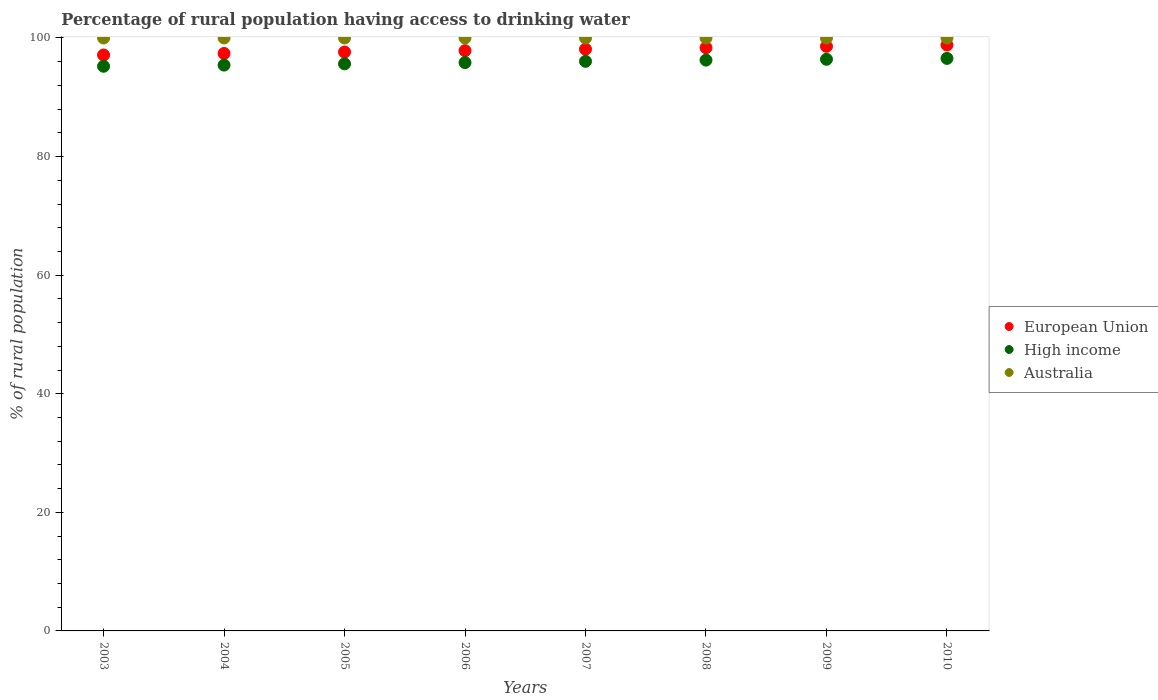How many different coloured dotlines are there?
Provide a succinct answer. 3. Is the number of dotlines equal to the number of legend labels?
Provide a short and direct response. Yes. What is the percentage of rural population having access to drinking water in Australia in 2008?
Make the answer very short. 100. Across all years, what is the maximum percentage of rural population having access to drinking water in Australia?
Ensure brevity in your answer.  100. Across all years, what is the minimum percentage of rural population having access to drinking water in High income?
Ensure brevity in your answer.  95.23. In which year was the percentage of rural population having access to drinking water in High income maximum?
Ensure brevity in your answer.  2010. In which year was the percentage of rural population having access to drinking water in European Union minimum?
Ensure brevity in your answer.  2003. What is the total percentage of rural population having access to drinking water in European Union in the graph?
Give a very brief answer. 783.89. What is the difference between the percentage of rural population having access to drinking water in European Union in 2006 and that in 2007?
Provide a short and direct response. -0.24. What is the difference between the percentage of rural population having access to drinking water in Australia in 2003 and the percentage of rural population having access to drinking water in High income in 2009?
Ensure brevity in your answer.  3.59. What is the average percentage of rural population having access to drinking water in European Union per year?
Offer a terse response. 97.99. In the year 2007, what is the difference between the percentage of rural population having access to drinking water in European Union and percentage of rural population having access to drinking water in Australia?
Your answer should be very brief. -1.89. In how many years, is the percentage of rural population having access to drinking water in High income greater than 88 %?
Make the answer very short. 8. What is the ratio of the percentage of rural population having access to drinking water in European Union in 2004 to that in 2006?
Your answer should be compact. 1. Is the percentage of rural population having access to drinking water in High income in 2003 less than that in 2006?
Give a very brief answer. Yes. Is the difference between the percentage of rural population having access to drinking water in European Union in 2007 and 2008 greater than the difference between the percentage of rural population having access to drinking water in Australia in 2007 and 2008?
Ensure brevity in your answer.  No. What is the difference between the highest and the second highest percentage of rural population having access to drinking water in High income?
Offer a terse response. 0.15. What is the difference between the highest and the lowest percentage of rural population having access to drinking water in European Union?
Your response must be concise. 1.68. Is it the case that in every year, the sum of the percentage of rural population having access to drinking water in European Union and percentage of rural population having access to drinking water in Australia  is greater than the percentage of rural population having access to drinking water in High income?
Your answer should be compact. Yes. Is the percentage of rural population having access to drinking water in European Union strictly less than the percentage of rural population having access to drinking water in Australia over the years?
Keep it short and to the point. Yes. How many dotlines are there?
Offer a terse response. 3. Are the values on the major ticks of Y-axis written in scientific E-notation?
Your answer should be very brief. No. Where does the legend appear in the graph?
Offer a very short reply. Center right. How many legend labels are there?
Give a very brief answer. 3. What is the title of the graph?
Keep it short and to the point. Percentage of rural population having access to drinking water. Does "Palau" appear as one of the legend labels in the graph?
Keep it short and to the point. No. What is the label or title of the X-axis?
Your answer should be compact. Years. What is the label or title of the Y-axis?
Your response must be concise. % of rural population. What is the % of rural population in European Union in 2003?
Keep it short and to the point. 97.13. What is the % of rural population in High income in 2003?
Offer a very short reply. 95.23. What is the % of rural population of Australia in 2003?
Offer a very short reply. 100. What is the % of rural population in European Union in 2004?
Provide a short and direct response. 97.39. What is the % of rural population of High income in 2004?
Your response must be concise. 95.43. What is the % of rural population of Australia in 2004?
Your answer should be very brief. 100. What is the % of rural population of European Union in 2005?
Your response must be concise. 97.63. What is the % of rural population in High income in 2005?
Keep it short and to the point. 95.64. What is the % of rural population in Australia in 2005?
Your answer should be very brief. 100. What is the % of rural population in European Union in 2006?
Provide a short and direct response. 97.87. What is the % of rural population of High income in 2006?
Ensure brevity in your answer.  95.85. What is the % of rural population of Australia in 2006?
Offer a terse response. 100. What is the % of rural population of European Union in 2007?
Make the answer very short. 98.11. What is the % of rural population of High income in 2007?
Offer a terse response. 96.06. What is the % of rural population of Australia in 2007?
Offer a terse response. 100. What is the % of rural population of European Union in 2008?
Ensure brevity in your answer.  98.35. What is the % of rural population in High income in 2008?
Offer a very short reply. 96.27. What is the % of rural population of Australia in 2008?
Your answer should be very brief. 100. What is the % of rural population in European Union in 2009?
Offer a terse response. 98.59. What is the % of rural population of High income in 2009?
Your response must be concise. 96.41. What is the % of rural population in Australia in 2009?
Make the answer very short. 100. What is the % of rural population of European Union in 2010?
Provide a succinct answer. 98.81. What is the % of rural population of High income in 2010?
Provide a short and direct response. 96.56. What is the % of rural population of Australia in 2010?
Your answer should be very brief. 100. Across all years, what is the maximum % of rural population of European Union?
Ensure brevity in your answer.  98.81. Across all years, what is the maximum % of rural population in High income?
Keep it short and to the point. 96.56. Across all years, what is the maximum % of rural population in Australia?
Give a very brief answer. 100. Across all years, what is the minimum % of rural population of European Union?
Offer a terse response. 97.13. Across all years, what is the minimum % of rural population of High income?
Keep it short and to the point. 95.23. Across all years, what is the minimum % of rural population of Australia?
Keep it short and to the point. 100. What is the total % of rural population of European Union in the graph?
Give a very brief answer. 783.89. What is the total % of rural population of High income in the graph?
Keep it short and to the point. 767.45. What is the total % of rural population in Australia in the graph?
Make the answer very short. 800. What is the difference between the % of rural population of European Union in 2003 and that in 2004?
Ensure brevity in your answer.  -0.26. What is the difference between the % of rural population of High income in 2003 and that in 2004?
Offer a terse response. -0.2. What is the difference between the % of rural population of Australia in 2003 and that in 2004?
Provide a succinct answer. 0. What is the difference between the % of rural population of European Union in 2003 and that in 2005?
Your answer should be very brief. -0.5. What is the difference between the % of rural population in High income in 2003 and that in 2005?
Your response must be concise. -0.41. What is the difference between the % of rural population in European Union in 2003 and that in 2006?
Keep it short and to the point. -0.73. What is the difference between the % of rural population in High income in 2003 and that in 2006?
Give a very brief answer. -0.62. What is the difference between the % of rural population in Australia in 2003 and that in 2006?
Offer a terse response. 0. What is the difference between the % of rural population in European Union in 2003 and that in 2007?
Your answer should be compact. -0.98. What is the difference between the % of rural population in High income in 2003 and that in 2007?
Your response must be concise. -0.83. What is the difference between the % of rural population of Australia in 2003 and that in 2007?
Your answer should be very brief. 0. What is the difference between the % of rural population of European Union in 2003 and that in 2008?
Offer a terse response. -1.22. What is the difference between the % of rural population in High income in 2003 and that in 2008?
Your answer should be compact. -1.04. What is the difference between the % of rural population in European Union in 2003 and that in 2009?
Provide a succinct answer. -1.46. What is the difference between the % of rural population in High income in 2003 and that in 2009?
Ensure brevity in your answer.  -1.18. What is the difference between the % of rural population in European Union in 2003 and that in 2010?
Provide a succinct answer. -1.68. What is the difference between the % of rural population in High income in 2003 and that in 2010?
Offer a terse response. -1.33. What is the difference between the % of rural population in European Union in 2004 and that in 2005?
Make the answer very short. -0.24. What is the difference between the % of rural population of High income in 2004 and that in 2005?
Offer a terse response. -0.21. What is the difference between the % of rural population in Australia in 2004 and that in 2005?
Provide a succinct answer. 0. What is the difference between the % of rural population of European Union in 2004 and that in 2006?
Give a very brief answer. -0.48. What is the difference between the % of rural population in High income in 2004 and that in 2006?
Offer a terse response. -0.43. What is the difference between the % of rural population of Australia in 2004 and that in 2006?
Your answer should be very brief. 0. What is the difference between the % of rural population of European Union in 2004 and that in 2007?
Provide a short and direct response. -0.72. What is the difference between the % of rural population in High income in 2004 and that in 2007?
Provide a succinct answer. -0.64. What is the difference between the % of rural population of Australia in 2004 and that in 2007?
Provide a succinct answer. 0. What is the difference between the % of rural population of European Union in 2004 and that in 2008?
Your response must be concise. -0.96. What is the difference between the % of rural population of High income in 2004 and that in 2008?
Provide a succinct answer. -0.84. What is the difference between the % of rural population in Australia in 2004 and that in 2008?
Offer a very short reply. 0. What is the difference between the % of rural population of European Union in 2004 and that in 2009?
Your response must be concise. -1.2. What is the difference between the % of rural population of High income in 2004 and that in 2009?
Give a very brief answer. -0.98. What is the difference between the % of rural population in Australia in 2004 and that in 2009?
Your answer should be very brief. 0. What is the difference between the % of rural population of European Union in 2004 and that in 2010?
Provide a succinct answer. -1.42. What is the difference between the % of rural population in High income in 2004 and that in 2010?
Your answer should be compact. -1.13. What is the difference between the % of rural population in Australia in 2004 and that in 2010?
Your answer should be very brief. 0. What is the difference between the % of rural population in European Union in 2005 and that in 2006?
Provide a short and direct response. -0.24. What is the difference between the % of rural population of High income in 2005 and that in 2006?
Offer a very short reply. -0.21. What is the difference between the % of rural population of European Union in 2005 and that in 2007?
Offer a terse response. -0.48. What is the difference between the % of rural population in High income in 2005 and that in 2007?
Your response must be concise. -0.42. What is the difference between the % of rural population in European Union in 2005 and that in 2008?
Your response must be concise. -0.72. What is the difference between the % of rural population of High income in 2005 and that in 2008?
Your answer should be compact. -0.63. What is the difference between the % of rural population of European Union in 2005 and that in 2009?
Ensure brevity in your answer.  -0.96. What is the difference between the % of rural population in High income in 2005 and that in 2009?
Provide a succinct answer. -0.77. What is the difference between the % of rural population of Australia in 2005 and that in 2009?
Provide a succinct answer. 0. What is the difference between the % of rural population in European Union in 2005 and that in 2010?
Make the answer very short. -1.18. What is the difference between the % of rural population in High income in 2005 and that in 2010?
Your answer should be compact. -0.92. What is the difference between the % of rural population in Australia in 2005 and that in 2010?
Provide a short and direct response. 0. What is the difference between the % of rural population in European Union in 2006 and that in 2007?
Make the answer very short. -0.24. What is the difference between the % of rural population of High income in 2006 and that in 2007?
Offer a terse response. -0.21. What is the difference between the % of rural population in European Union in 2006 and that in 2008?
Your answer should be very brief. -0.49. What is the difference between the % of rural population in High income in 2006 and that in 2008?
Keep it short and to the point. -0.41. What is the difference between the % of rural population in European Union in 2006 and that in 2009?
Your answer should be compact. -0.72. What is the difference between the % of rural population of High income in 2006 and that in 2009?
Provide a short and direct response. -0.55. What is the difference between the % of rural population in European Union in 2006 and that in 2010?
Your response must be concise. -0.95. What is the difference between the % of rural population of High income in 2006 and that in 2010?
Ensure brevity in your answer.  -0.7. What is the difference between the % of rural population of European Union in 2007 and that in 2008?
Make the answer very short. -0.24. What is the difference between the % of rural population of High income in 2007 and that in 2008?
Your response must be concise. -0.21. What is the difference between the % of rural population of Australia in 2007 and that in 2008?
Provide a succinct answer. 0. What is the difference between the % of rural population in European Union in 2007 and that in 2009?
Provide a short and direct response. -0.48. What is the difference between the % of rural population of High income in 2007 and that in 2009?
Offer a terse response. -0.34. What is the difference between the % of rural population of Australia in 2007 and that in 2009?
Your answer should be compact. 0. What is the difference between the % of rural population in European Union in 2007 and that in 2010?
Make the answer very short. -0.7. What is the difference between the % of rural population in High income in 2007 and that in 2010?
Your answer should be compact. -0.49. What is the difference between the % of rural population of Australia in 2007 and that in 2010?
Your answer should be very brief. 0. What is the difference between the % of rural population in European Union in 2008 and that in 2009?
Make the answer very short. -0.24. What is the difference between the % of rural population in High income in 2008 and that in 2009?
Offer a very short reply. -0.14. What is the difference between the % of rural population of Australia in 2008 and that in 2009?
Ensure brevity in your answer.  0. What is the difference between the % of rural population in European Union in 2008 and that in 2010?
Provide a succinct answer. -0.46. What is the difference between the % of rural population of High income in 2008 and that in 2010?
Provide a succinct answer. -0.29. What is the difference between the % of rural population of Australia in 2008 and that in 2010?
Provide a succinct answer. 0. What is the difference between the % of rural population in European Union in 2009 and that in 2010?
Ensure brevity in your answer.  -0.22. What is the difference between the % of rural population in High income in 2009 and that in 2010?
Provide a short and direct response. -0.15. What is the difference between the % of rural population in European Union in 2003 and the % of rural population in High income in 2004?
Provide a succinct answer. 1.71. What is the difference between the % of rural population of European Union in 2003 and the % of rural population of Australia in 2004?
Your response must be concise. -2.87. What is the difference between the % of rural population in High income in 2003 and the % of rural population in Australia in 2004?
Keep it short and to the point. -4.77. What is the difference between the % of rural population in European Union in 2003 and the % of rural population in High income in 2005?
Offer a very short reply. 1.49. What is the difference between the % of rural population of European Union in 2003 and the % of rural population of Australia in 2005?
Keep it short and to the point. -2.87. What is the difference between the % of rural population of High income in 2003 and the % of rural population of Australia in 2005?
Your answer should be compact. -4.77. What is the difference between the % of rural population in European Union in 2003 and the % of rural population in High income in 2006?
Your answer should be compact. 1.28. What is the difference between the % of rural population in European Union in 2003 and the % of rural population in Australia in 2006?
Offer a terse response. -2.87. What is the difference between the % of rural population of High income in 2003 and the % of rural population of Australia in 2006?
Ensure brevity in your answer.  -4.77. What is the difference between the % of rural population in European Union in 2003 and the % of rural population in High income in 2007?
Keep it short and to the point. 1.07. What is the difference between the % of rural population of European Union in 2003 and the % of rural population of Australia in 2007?
Give a very brief answer. -2.87. What is the difference between the % of rural population of High income in 2003 and the % of rural population of Australia in 2007?
Give a very brief answer. -4.77. What is the difference between the % of rural population in European Union in 2003 and the % of rural population in High income in 2008?
Make the answer very short. 0.86. What is the difference between the % of rural population of European Union in 2003 and the % of rural population of Australia in 2008?
Give a very brief answer. -2.87. What is the difference between the % of rural population of High income in 2003 and the % of rural population of Australia in 2008?
Make the answer very short. -4.77. What is the difference between the % of rural population of European Union in 2003 and the % of rural population of High income in 2009?
Make the answer very short. 0.73. What is the difference between the % of rural population in European Union in 2003 and the % of rural population in Australia in 2009?
Offer a very short reply. -2.87. What is the difference between the % of rural population of High income in 2003 and the % of rural population of Australia in 2009?
Ensure brevity in your answer.  -4.77. What is the difference between the % of rural population of European Union in 2003 and the % of rural population of High income in 2010?
Your answer should be compact. 0.58. What is the difference between the % of rural population of European Union in 2003 and the % of rural population of Australia in 2010?
Your answer should be very brief. -2.87. What is the difference between the % of rural population of High income in 2003 and the % of rural population of Australia in 2010?
Offer a terse response. -4.77. What is the difference between the % of rural population in European Union in 2004 and the % of rural population in High income in 2005?
Your response must be concise. 1.75. What is the difference between the % of rural population in European Union in 2004 and the % of rural population in Australia in 2005?
Make the answer very short. -2.61. What is the difference between the % of rural population of High income in 2004 and the % of rural population of Australia in 2005?
Provide a short and direct response. -4.57. What is the difference between the % of rural population of European Union in 2004 and the % of rural population of High income in 2006?
Your answer should be compact. 1.54. What is the difference between the % of rural population of European Union in 2004 and the % of rural population of Australia in 2006?
Your response must be concise. -2.61. What is the difference between the % of rural population of High income in 2004 and the % of rural population of Australia in 2006?
Your answer should be compact. -4.57. What is the difference between the % of rural population of European Union in 2004 and the % of rural population of High income in 2007?
Provide a short and direct response. 1.33. What is the difference between the % of rural population of European Union in 2004 and the % of rural population of Australia in 2007?
Provide a short and direct response. -2.61. What is the difference between the % of rural population in High income in 2004 and the % of rural population in Australia in 2007?
Provide a short and direct response. -4.57. What is the difference between the % of rural population of European Union in 2004 and the % of rural population of High income in 2008?
Your answer should be compact. 1.12. What is the difference between the % of rural population of European Union in 2004 and the % of rural population of Australia in 2008?
Your answer should be very brief. -2.61. What is the difference between the % of rural population in High income in 2004 and the % of rural population in Australia in 2008?
Your answer should be compact. -4.57. What is the difference between the % of rural population in European Union in 2004 and the % of rural population in High income in 2009?
Provide a short and direct response. 0.98. What is the difference between the % of rural population of European Union in 2004 and the % of rural population of Australia in 2009?
Make the answer very short. -2.61. What is the difference between the % of rural population in High income in 2004 and the % of rural population in Australia in 2009?
Keep it short and to the point. -4.57. What is the difference between the % of rural population of European Union in 2004 and the % of rural population of High income in 2010?
Offer a terse response. 0.83. What is the difference between the % of rural population in European Union in 2004 and the % of rural population in Australia in 2010?
Ensure brevity in your answer.  -2.61. What is the difference between the % of rural population of High income in 2004 and the % of rural population of Australia in 2010?
Offer a very short reply. -4.57. What is the difference between the % of rural population of European Union in 2005 and the % of rural population of High income in 2006?
Ensure brevity in your answer.  1.78. What is the difference between the % of rural population of European Union in 2005 and the % of rural population of Australia in 2006?
Your response must be concise. -2.37. What is the difference between the % of rural population in High income in 2005 and the % of rural population in Australia in 2006?
Provide a succinct answer. -4.36. What is the difference between the % of rural population of European Union in 2005 and the % of rural population of High income in 2007?
Give a very brief answer. 1.57. What is the difference between the % of rural population in European Union in 2005 and the % of rural population in Australia in 2007?
Offer a terse response. -2.37. What is the difference between the % of rural population in High income in 2005 and the % of rural population in Australia in 2007?
Give a very brief answer. -4.36. What is the difference between the % of rural population of European Union in 2005 and the % of rural population of High income in 2008?
Keep it short and to the point. 1.36. What is the difference between the % of rural population of European Union in 2005 and the % of rural population of Australia in 2008?
Offer a very short reply. -2.37. What is the difference between the % of rural population in High income in 2005 and the % of rural population in Australia in 2008?
Ensure brevity in your answer.  -4.36. What is the difference between the % of rural population in European Union in 2005 and the % of rural population in High income in 2009?
Offer a very short reply. 1.22. What is the difference between the % of rural population of European Union in 2005 and the % of rural population of Australia in 2009?
Keep it short and to the point. -2.37. What is the difference between the % of rural population in High income in 2005 and the % of rural population in Australia in 2009?
Give a very brief answer. -4.36. What is the difference between the % of rural population of European Union in 2005 and the % of rural population of High income in 2010?
Keep it short and to the point. 1.07. What is the difference between the % of rural population in European Union in 2005 and the % of rural population in Australia in 2010?
Offer a terse response. -2.37. What is the difference between the % of rural population in High income in 2005 and the % of rural population in Australia in 2010?
Offer a terse response. -4.36. What is the difference between the % of rural population in European Union in 2006 and the % of rural population in High income in 2007?
Make the answer very short. 1.8. What is the difference between the % of rural population of European Union in 2006 and the % of rural population of Australia in 2007?
Make the answer very short. -2.13. What is the difference between the % of rural population of High income in 2006 and the % of rural population of Australia in 2007?
Provide a succinct answer. -4.15. What is the difference between the % of rural population of European Union in 2006 and the % of rural population of High income in 2008?
Your answer should be compact. 1.6. What is the difference between the % of rural population of European Union in 2006 and the % of rural population of Australia in 2008?
Offer a very short reply. -2.13. What is the difference between the % of rural population in High income in 2006 and the % of rural population in Australia in 2008?
Keep it short and to the point. -4.15. What is the difference between the % of rural population in European Union in 2006 and the % of rural population in High income in 2009?
Your answer should be compact. 1.46. What is the difference between the % of rural population in European Union in 2006 and the % of rural population in Australia in 2009?
Your response must be concise. -2.13. What is the difference between the % of rural population of High income in 2006 and the % of rural population of Australia in 2009?
Keep it short and to the point. -4.15. What is the difference between the % of rural population of European Union in 2006 and the % of rural population of High income in 2010?
Ensure brevity in your answer.  1.31. What is the difference between the % of rural population of European Union in 2006 and the % of rural population of Australia in 2010?
Keep it short and to the point. -2.13. What is the difference between the % of rural population of High income in 2006 and the % of rural population of Australia in 2010?
Offer a terse response. -4.15. What is the difference between the % of rural population of European Union in 2007 and the % of rural population of High income in 2008?
Provide a succinct answer. 1.84. What is the difference between the % of rural population of European Union in 2007 and the % of rural population of Australia in 2008?
Your answer should be very brief. -1.89. What is the difference between the % of rural population in High income in 2007 and the % of rural population in Australia in 2008?
Offer a very short reply. -3.94. What is the difference between the % of rural population in European Union in 2007 and the % of rural population in High income in 2009?
Your response must be concise. 1.7. What is the difference between the % of rural population of European Union in 2007 and the % of rural population of Australia in 2009?
Ensure brevity in your answer.  -1.89. What is the difference between the % of rural population in High income in 2007 and the % of rural population in Australia in 2009?
Keep it short and to the point. -3.94. What is the difference between the % of rural population in European Union in 2007 and the % of rural population in High income in 2010?
Offer a very short reply. 1.55. What is the difference between the % of rural population of European Union in 2007 and the % of rural population of Australia in 2010?
Make the answer very short. -1.89. What is the difference between the % of rural population in High income in 2007 and the % of rural population in Australia in 2010?
Provide a succinct answer. -3.94. What is the difference between the % of rural population of European Union in 2008 and the % of rural population of High income in 2009?
Ensure brevity in your answer.  1.95. What is the difference between the % of rural population of European Union in 2008 and the % of rural population of Australia in 2009?
Provide a short and direct response. -1.65. What is the difference between the % of rural population in High income in 2008 and the % of rural population in Australia in 2009?
Your response must be concise. -3.73. What is the difference between the % of rural population of European Union in 2008 and the % of rural population of High income in 2010?
Provide a succinct answer. 1.8. What is the difference between the % of rural population in European Union in 2008 and the % of rural population in Australia in 2010?
Keep it short and to the point. -1.65. What is the difference between the % of rural population in High income in 2008 and the % of rural population in Australia in 2010?
Give a very brief answer. -3.73. What is the difference between the % of rural population in European Union in 2009 and the % of rural population in High income in 2010?
Provide a succinct answer. 2.03. What is the difference between the % of rural population in European Union in 2009 and the % of rural population in Australia in 2010?
Make the answer very short. -1.41. What is the difference between the % of rural population of High income in 2009 and the % of rural population of Australia in 2010?
Ensure brevity in your answer.  -3.59. What is the average % of rural population in European Union per year?
Ensure brevity in your answer.  97.99. What is the average % of rural population of High income per year?
Keep it short and to the point. 95.93. In the year 2003, what is the difference between the % of rural population of European Union and % of rural population of High income?
Make the answer very short. 1.9. In the year 2003, what is the difference between the % of rural population in European Union and % of rural population in Australia?
Your answer should be compact. -2.87. In the year 2003, what is the difference between the % of rural population in High income and % of rural population in Australia?
Your response must be concise. -4.77. In the year 2004, what is the difference between the % of rural population in European Union and % of rural population in High income?
Give a very brief answer. 1.96. In the year 2004, what is the difference between the % of rural population in European Union and % of rural population in Australia?
Provide a succinct answer. -2.61. In the year 2004, what is the difference between the % of rural population of High income and % of rural population of Australia?
Your answer should be very brief. -4.57. In the year 2005, what is the difference between the % of rural population of European Union and % of rural population of High income?
Offer a very short reply. 1.99. In the year 2005, what is the difference between the % of rural population in European Union and % of rural population in Australia?
Your response must be concise. -2.37. In the year 2005, what is the difference between the % of rural population of High income and % of rural population of Australia?
Provide a short and direct response. -4.36. In the year 2006, what is the difference between the % of rural population in European Union and % of rural population in High income?
Give a very brief answer. 2.01. In the year 2006, what is the difference between the % of rural population of European Union and % of rural population of Australia?
Offer a very short reply. -2.13. In the year 2006, what is the difference between the % of rural population in High income and % of rural population in Australia?
Your response must be concise. -4.15. In the year 2007, what is the difference between the % of rural population of European Union and % of rural population of High income?
Your answer should be compact. 2.05. In the year 2007, what is the difference between the % of rural population of European Union and % of rural population of Australia?
Offer a very short reply. -1.89. In the year 2007, what is the difference between the % of rural population of High income and % of rural population of Australia?
Keep it short and to the point. -3.94. In the year 2008, what is the difference between the % of rural population in European Union and % of rural population in High income?
Provide a short and direct response. 2.08. In the year 2008, what is the difference between the % of rural population of European Union and % of rural population of Australia?
Your response must be concise. -1.65. In the year 2008, what is the difference between the % of rural population in High income and % of rural population in Australia?
Provide a short and direct response. -3.73. In the year 2009, what is the difference between the % of rural population of European Union and % of rural population of High income?
Your answer should be very brief. 2.18. In the year 2009, what is the difference between the % of rural population in European Union and % of rural population in Australia?
Provide a short and direct response. -1.41. In the year 2009, what is the difference between the % of rural population of High income and % of rural population of Australia?
Provide a succinct answer. -3.59. In the year 2010, what is the difference between the % of rural population of European Union and % of rural population of High income?
Provide a succinct answer. 2.26. In the year 2010, what is the difference between the % of rural population of European Union and % of rural population of Australia?
Give a very brief answer. -1.19. In the year 2010, what is the difference between the % of rural population in High income and % of rural population in Australia?
Make the answer very short. -3.44. What is the ratio of the % of rural population in Australia in 2003 to that in 2004?
Your answer should be very brief. 1. What is the ratio of the % of rural population in European Union in 2003 to that in 2005?
Provide a succinct answer. 0.99. What is the ratio of the % of rural population in High income in 2003 to that in 2005?
Your answer should be compact. 1. What is the ratio of the % of rural population in European Union in 2003 to that in 2006?
Keep it short and to the point. 0.99. What is the ratio of the % of rural population in High income in 2003 to that in 2006?
Ensure brevity in your answer.  0.99. What is the ratio of the % of rural population of Australia in 2003 to that in 2006?
Keep it short and to the point. 1. What is the ratio of the % of rural population of High income in 2003 to that in 2007?
Ensure brevity in your answer.  0.99. What is the ratio of the % of rural population of European Union in 2003 to that in 2008?
Your answer should be compact. 0.99. What is the ratio of the % of rural population of European Union in 2003 to that in 2009?
Provide a succinct answer. 0.99. What is the ratio of the % of rural population of High income in 2003 to that in 2010?
Offer a terse response. 0.99. What is the ratio of the % of rural population in European Union in 2004 to that in 2005?
Your response must be concise. 1. What is the ratio of the % of rural population of High income in 2004 to that in 2005?
Provide a short and direct response. 1. What is the ratio of the % of rural population of Australia in 2004 to that in 2005?
Your response must be concise. 1. What is the ratio of the % of rural population in European Union in 2004 to that in 2006?
Give a very brief answer. 1. What is the ratio of the % of rural population in High income in 2004 to that in 2006?
Ensure brevity in your answer.  1. What is the ratio of the % of rural population of High income in 2004 to that in 2007?
Ensure brevity in your answer.  0.99. What is the ratio of the % of rural population of Australia in 2004 to that in 2007?
Make the answer very short. 1. What is the ratio of the % of rural population in European Union in 2004 to that in 2008?
Offer a terse response. 0.99. What is the ratio of the % of rural population in High income in 2004 to that in 2009?
Offer a very short reply. 0.99. What is the ratio of the % of rural population in European Union in 2004 to that in 2010?
Offer a terse response. 0.99. What is the ratio of the % of rural population in High income in 2004 to that in 2010?
Your response must be concise. 0.99. What is the ratio of the % of rural population in Australia in 2004 to that in 2010?
Offer a terse response. 1. What is the ratio of the % of rural population of European Union in 2005 to that in 2006?
Keep it short and to the point. 1. What is the ratio of the % of rural population of High income in 2005 to that in 2006?
Make the answer very short. 1. What is the ratio of the % of rural population of European Union in 2005 to that in 2007?
Offer a terse response. 1. What is the ratio of the % of rural population of European Union in 2005 to that in 2008?
Offer a terse response. 0.99. What is the ratio of the % of rural population of European Union in 2005 to that in 2009?
Offer a terse response. 0.99. What is the ratio of the % of rural population in High income in 2005 to that in 2009?
Keep it short and to the point. 0.99. What is the ratio of the % of rural population of Australia in 2006 to that in 2007?
Your answer should be compact. 1. What is the ratio of the % of rural population in European Union in 2006 to that in 2008?
Your answer should be compact. 1. What is the ratio of the % of rural population of High income in 2006 to that in 2008?
Offer a terse response. 1. What is the ratio of the % of rural population in Australia in 2006 to that in 2008?
Make the answer very short. 1. What is the ratio of the % of rural population in European Union in 2006 to that in 2009?
Your response must be concise. 0.99. What is the ratio of the % of rural population of High income in 2006 to that in 2009?
Ensure brevity in your answer.  0.99. What is the ratio of the % of rural population of Australia in 2006 to that in 2009?
Make the answer very short. 1. What is the ratio of the % of rural population in European Union in 2007 to that in 2008?
Provide a short and direct response. 1. What is the ratio of the % of rural population of High income in 2007 to that in 2009?
Give a very brief answer. 1. What is the ratio of the % of rural population of Australia in 2007 to that in 2009?
Keep it short and to the point. 1. What is the ratio of the % of rural population in European Union in 2007 to that in 2010?
Give a very brief answer. 0.99. What is the ratio of the % of rural population in High income in 2007 to that in 2010?
Keep it short and to the point. 0.99. What is the ratio of the % of rural population in Australia in 2007 to that in 2010?
Offer a terse response. 1. What is the ratio of the % of rural population in European Union in 2008 to that in 2010?
Offer a terse response. 1. What is the ratio of the % of rural population of Australia in 2008 to that in 2010?
Give a very brief answer. 1. What is the ratio of the % of rural population of European Union in 2009 to that in 2010?
Provide a succinct answer. 1. What is the ratio of the % of rural population of High income in 2009 to that in 2010?
Provide a succinct answer. 1. What is the difference between the highest and the second highest % of rural population in European Union?
Give a very brief answer. 0.22. What is the difference between the highest and the second highest % of rural population of High income?
Ensure brevity in your answer.  0.15. What is the difference between the highest and the lowest % of rural population in European Union?
Your answer should be compact. 1.68. What is the difference between the highest and the lowest % of rural population of High income?
Your answer should be very brief. 1.33. What is the difference between the highest and the lowest % of rural population of Australia?
Give a very brief answer. 0. 